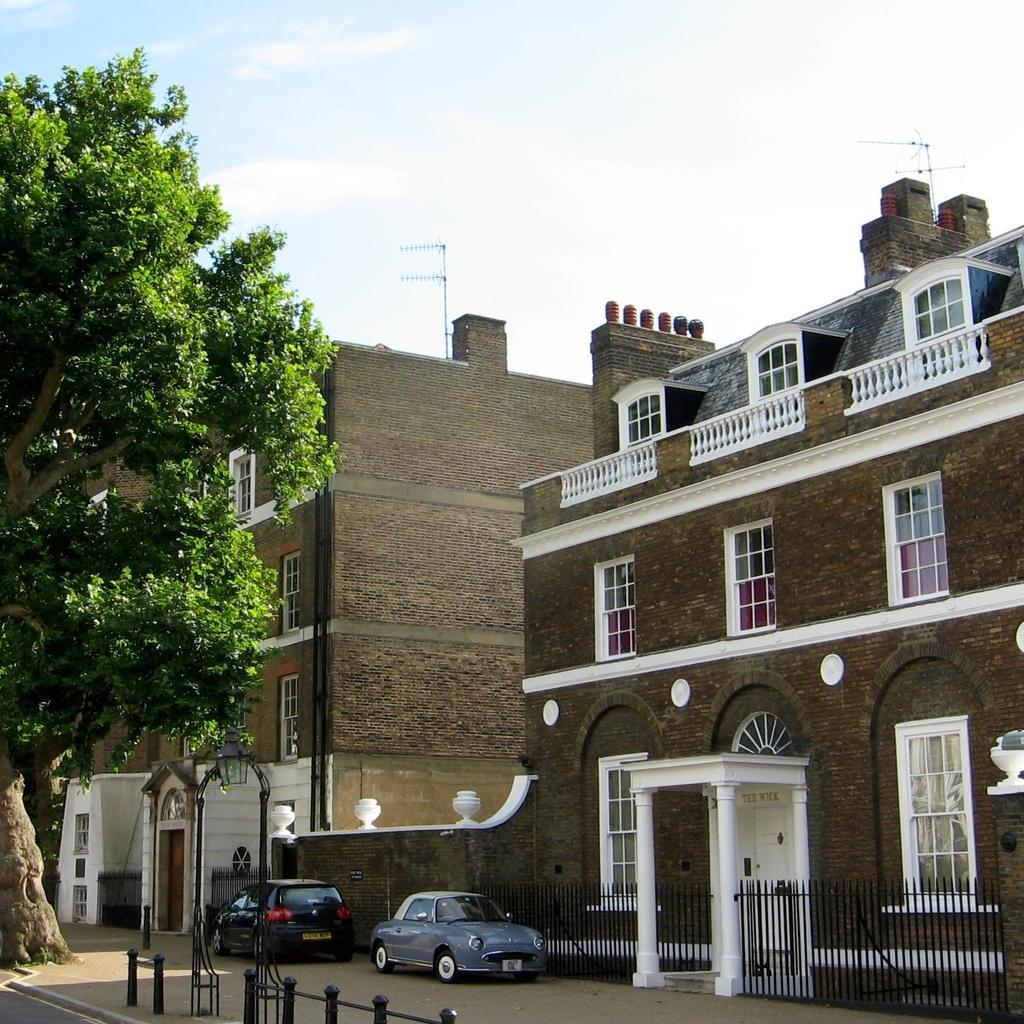How would you summarize this image in a sentence or two? There are buildings and two vehicles in the right corner and there is a tree in the left corner. 